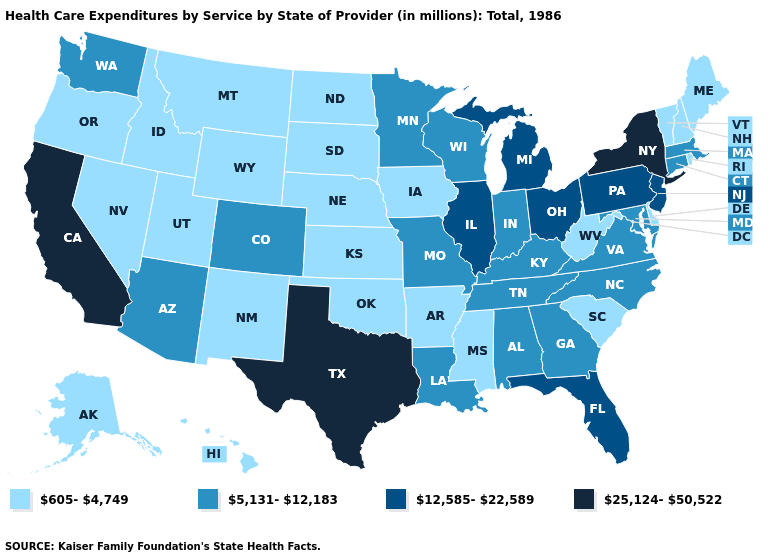Does the map have missing data?
Give a very brief answer. No. What is the lowest value in the USA?
Give a very brief answer. 605-4,749. What is the value of Hawaii?
Quick response, please. 605-4,749. What is the value of Arkansas?
Short answer required. 605-4,749. Does Vermont have the lowest value in the USA?
Quick response, please. Yes. Which states hav the highest value in the West?
Keep it brief. California. Name the states that have a value in the range 25,124-50,522?
Give a very brief answer. California, New York, Texas. What is the value of Texas?
Concise answer only. 25,124-50,522. Name the states that have a value in the range 605-4,749?
Short answer required. Alaska, Arkansas, Delaware, Hawaii, Idaho, Iowa, Kansas, Maine, Mississippi, Montana, Nebraska, Nevada, New Hampshire, New Mexico, North Dakota, Oklahoma, Oregon, Rhode Island, South Carolina, South Dakota, Utah, Vermont, West Virginia, Wyoming. What is the value of Ohio?
Short answer required. 12,585-22,589. What is the value of Alaska?
Short answer required. 605-4,749. What is the lowest value in the USA?
Answer briefly. 605-4,749. Is the legend a continuous bar?
Short answer required. No. What is the value of Virginia?
Write a very short answer. 5,131-12,183. What is the highest value in the West ?
Quick response, please. 25,124-50,522. 